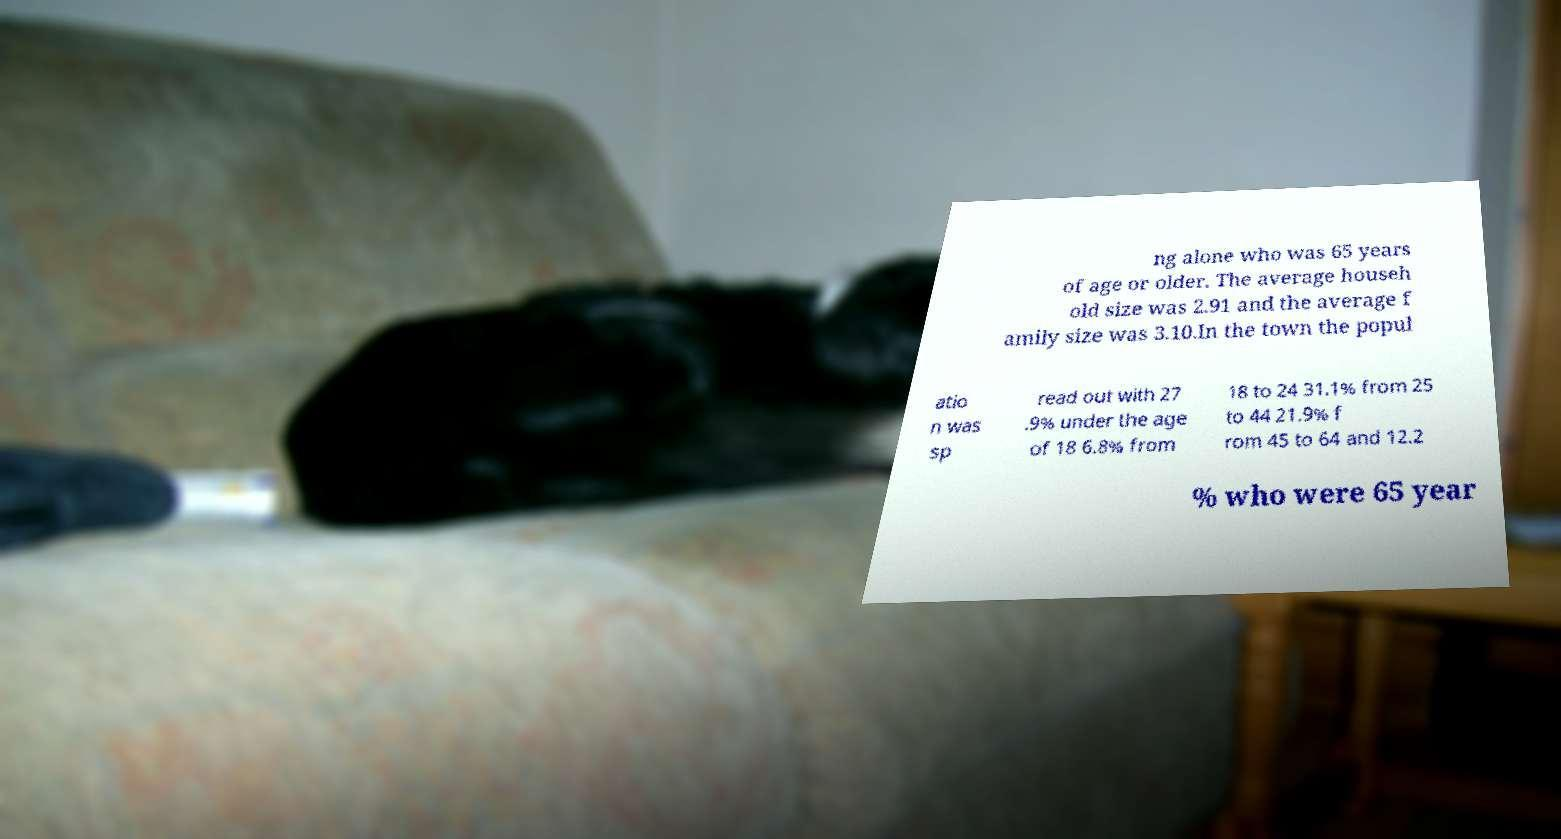There's text embedded in this image that I need extracted. Can you transcribe it verbatim? ng alone who was 65 years of age or older. The average househ old size was 2.91 and the average f amily size was 3.10.In the town the popul atio n was sp read out with 27 .9% under the age of 18 6.8% from 18 to 24 31.1% from 25 to 44 21.9% f rom 45 to 64 and 12.2 % who were 65 year 